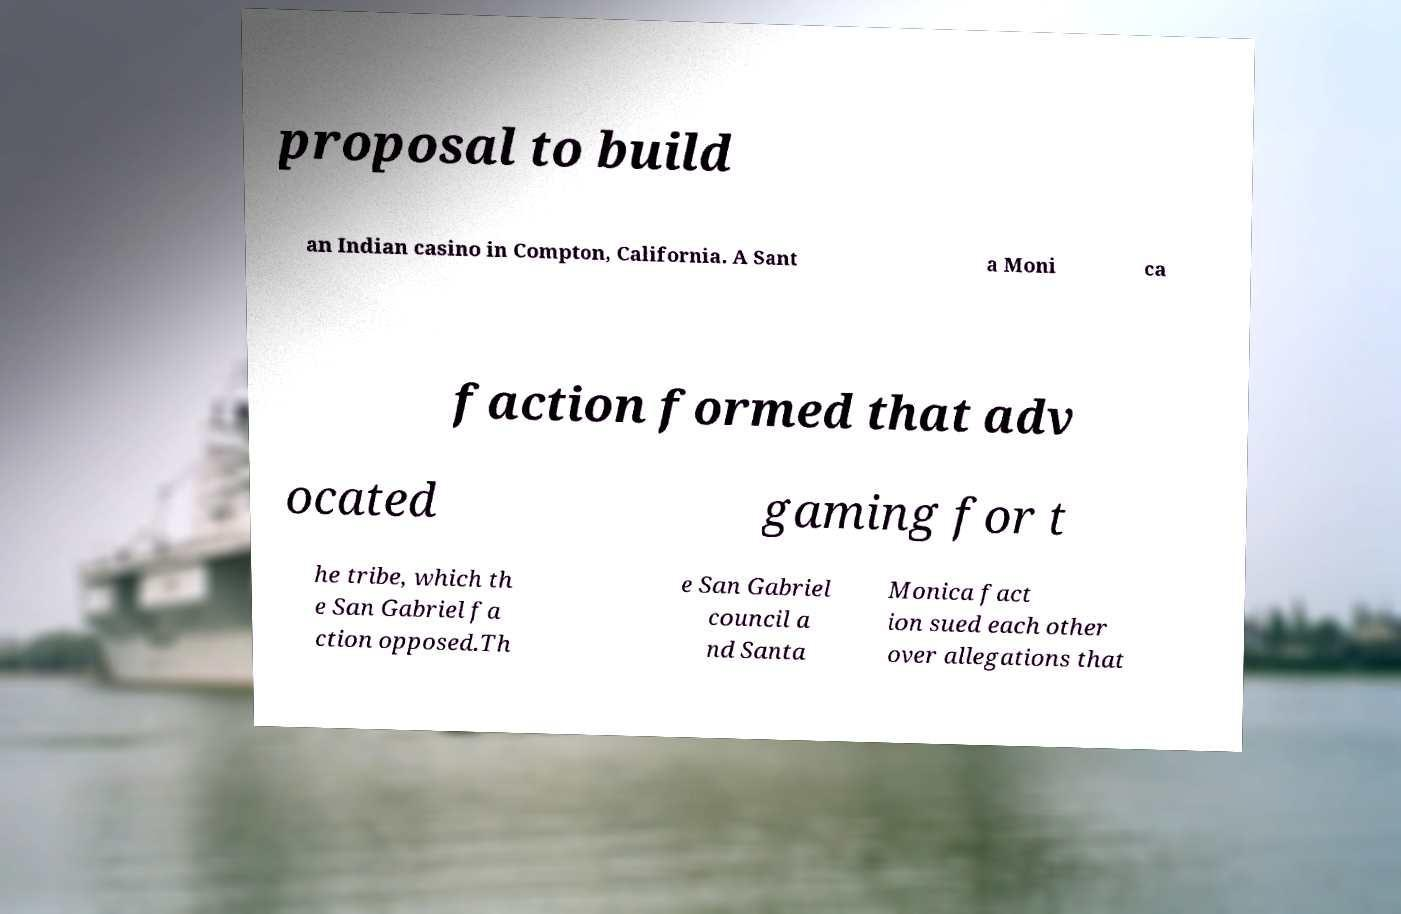Please read and relay the text visible in this image. What does it say? proposal to build an Indian casino in Compton, California. A Sant a Moni ca faction formed that adv ocated gaming for t he tribe, which th e San Gabriel fa ction opposed.Th e San Gabriel council a nd Santa Monica fact ion sued each other over allegations that 